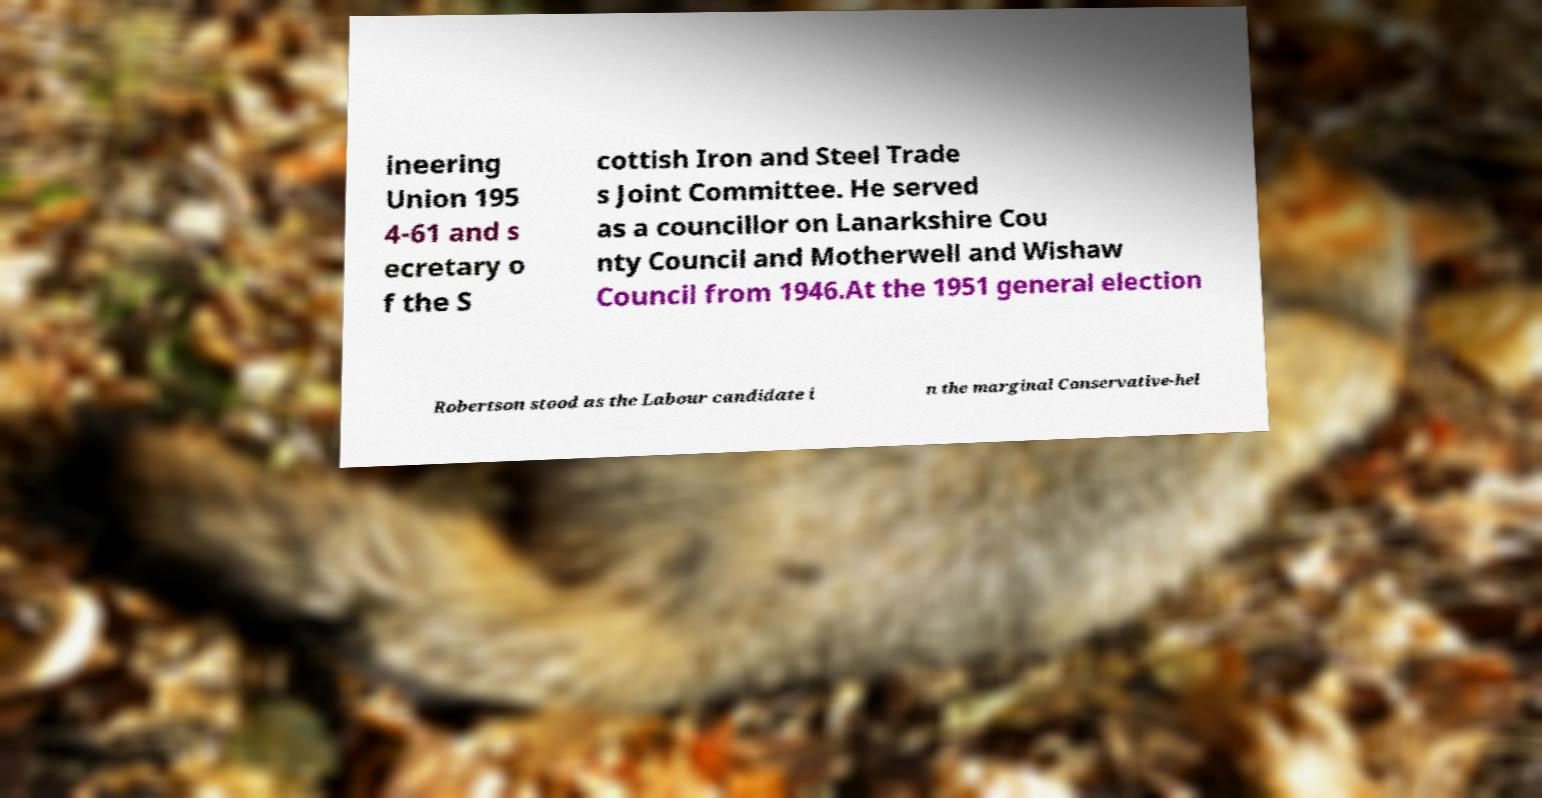I need the written content from this picture converted into text. Can you do that? ineering Union 195 4-61 and s ecretary o f the S cottish Iron and Steel Trade s Joint Committee. He served as a councillor on Lanarkshire Cou nty Council and Motherwell and Wishaw Council from 1946.At the 1951 general election Robertson stood as the Labour candidate i n the marginal Conservative-hel 